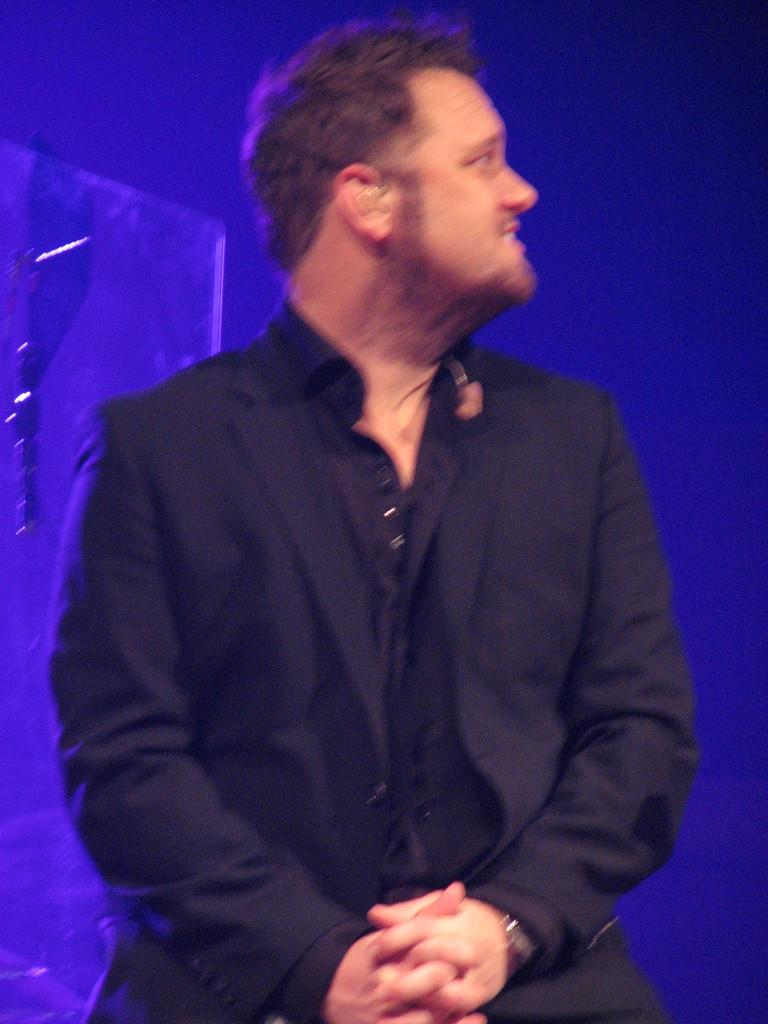What is the main subject of the image? There is a man standing in the center of the image. What is the man wearing? The man is wearing a suit. What can be seen in the background of the image? There is a blue light in the background of the image. Can you tell me how many trucks are parked next to the man in the image? There are no trucks present in the image; it only features a man standing in the center and a blue light in the background. 